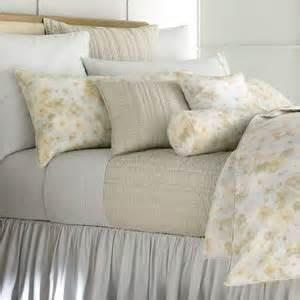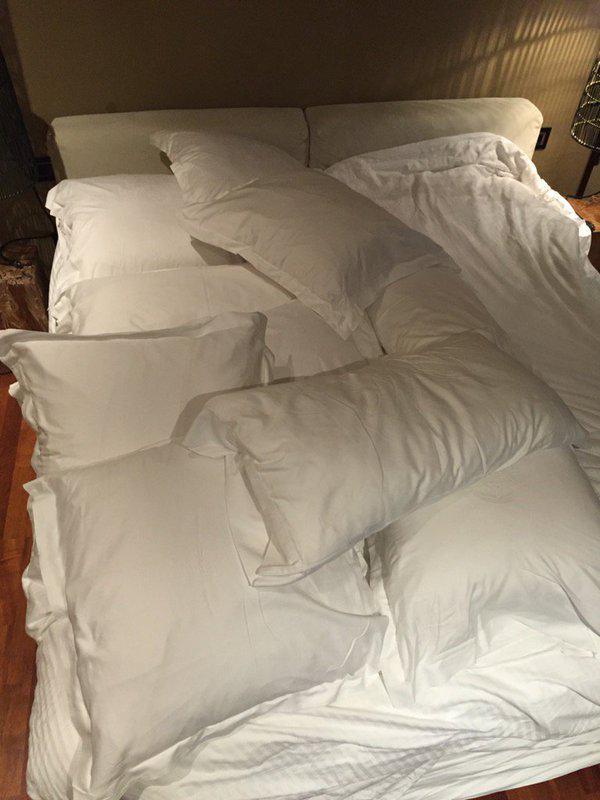The first image is the image on the left, the second image is the image on the right. For the images shown, is this caption "There is a vase of flowers in the image on the left." true? Answer yes or no. No. 